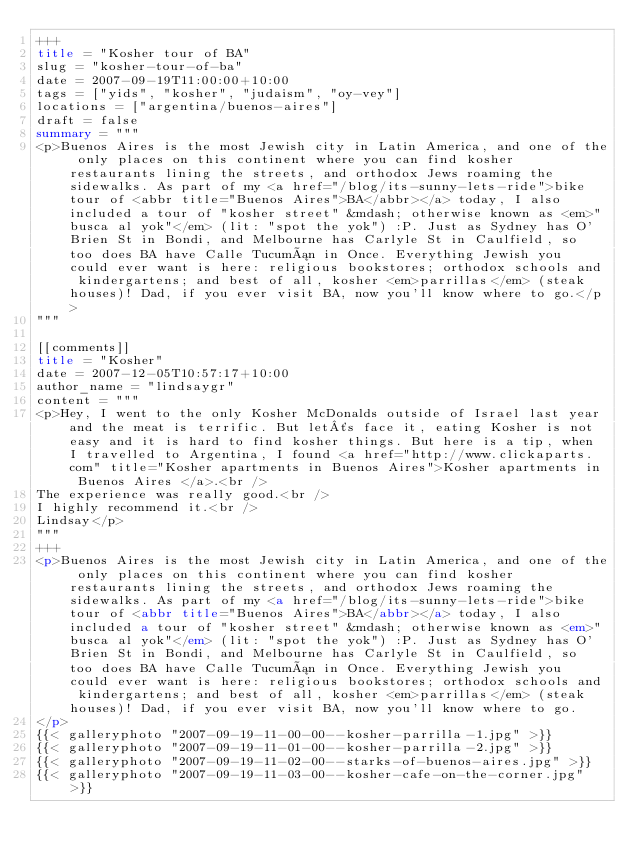Convert code to text. <code><loc_0><loc_0><loc_500><loc_500><_HTML_>+++
title = "Kosher tour of BA"
slug = "kosher-tour-of-ba"
date = 2007-09-19T11:00:00+10:00
tags = ["yids", "kosher", "judaism", "oy-vey"]
locations = ["argentina/buenos-aires"]
draft = false
summary = """
<p>Buenos Aires is the most Jewish city in Latin America, and one of the only places on this continent where you can find kosher restaurants lining the streets, and orthodox Jews roaming the sidewalks. As part of my <a href="/blog/its-sunny-lets-ride">bike tour of <abbr title="Buenos Aires">BA</abbr></a> today, I also included a tour of "kosher street" &mdash; otherwise known as <em>"busca al yok"</em> (lit: "spot the yok") :P. Just as Sydney has O'Brien St in Bondi, and Melbourne has Carlyle St in Caulfield, so too does BA have Calle Tucumán in Once. Everything Jewish you could ever want is here: religious bookstores; orthodox schools and kindergartens; and best of all, kosher <em>parrillas</em> (steak houses)! Dad, if you ever visit BA, now you'll know where to go.</p>
"""

[[comments]]
title = "Kosher"
date = 2007-12-05T10:57:17+10:00
author_name = "lindsaygr"
content = """
<p>Hey, I went to the only Kosher McDonalds outside of Israel last year and the meat is terrific. But let´s face it, eating Kosher is not easy and it is hard to find kosher things. But here is a tip, when I travelled to Argentina, I found <a href="http://www.clickaparts.com" title="Kosher apartments in Buenos Aires">Kosher apartments in Buenos Aires </a>.<br />
The experience was really good.<br />
I highly recommend it.<br />
Lindsay</p>
"""
+++
<p>Buenos Aires is the most Jewish city in Latin America, and one of the only places on this continent where you can find kosher restaurants lining the streets, and orthodox Jews roaming the sidewalks. As part of my <a href="/blog/its-sunny-lets-ride">bike tour of <abbr title="Buenos Aires">BA</abbr></a> today, I also included a tour of "kosher street" &mdash; otherwise known as <em>"busca al yok"</em> (lit: "spot the yok") :P. Just as Sydney has O'Brien St in Bondi, and Melbourne has Carlyle St in Caulfield, so too does BA have Calle Tucumán in Once. Everything Jewish you could ever want is here: religious bookstores; orthodox schools and kindergartens; and best of all, kosher <em>parrillas</em> (steak houses)! Dad, if you ever visit BA, now you'll know where to go.
</p>
{{< galleryphoto "2007-09-19-11-00-00--kosher-parrilla-1.jpg" >}}
{{< galleryphoto "2007-09-19-11-01-00--kosher-parrilla-2.jpg" >}}
{{< galleryphoto "2007-09-19-11-02-00--starks-of-buenos-aires.jpg" >}}
{{< galleryphoto "2007-09-19-11-03-00--kosher-cafe-on-the-corner.jpg" >}}</code> 